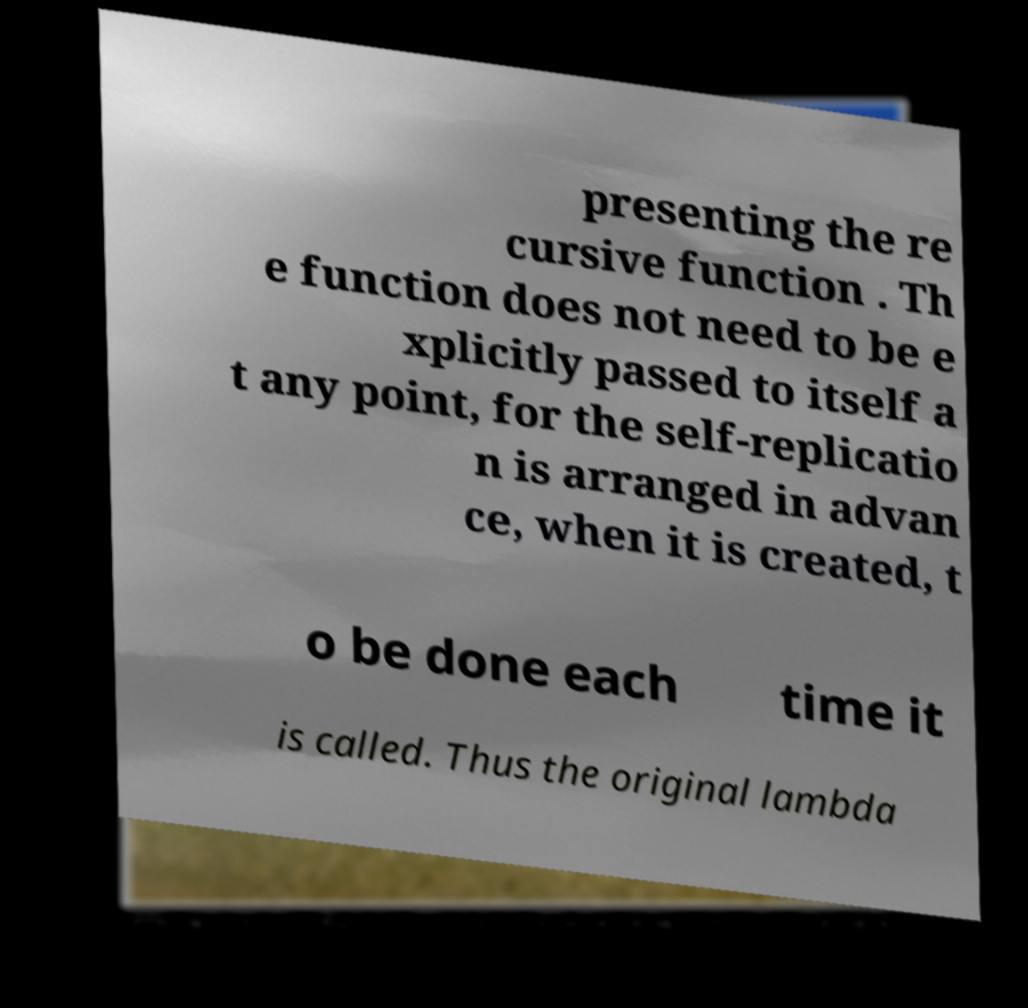For documentation purposes, I need the text within this image transcribed. Could you provide that? presenting the re cursive function . Th e function does not need to be e xplicitly passed to itself a t any point, for the self-replicatio n is arranged in advan ce, when it is created, t o be done each time it is called. Thus the original lambda 